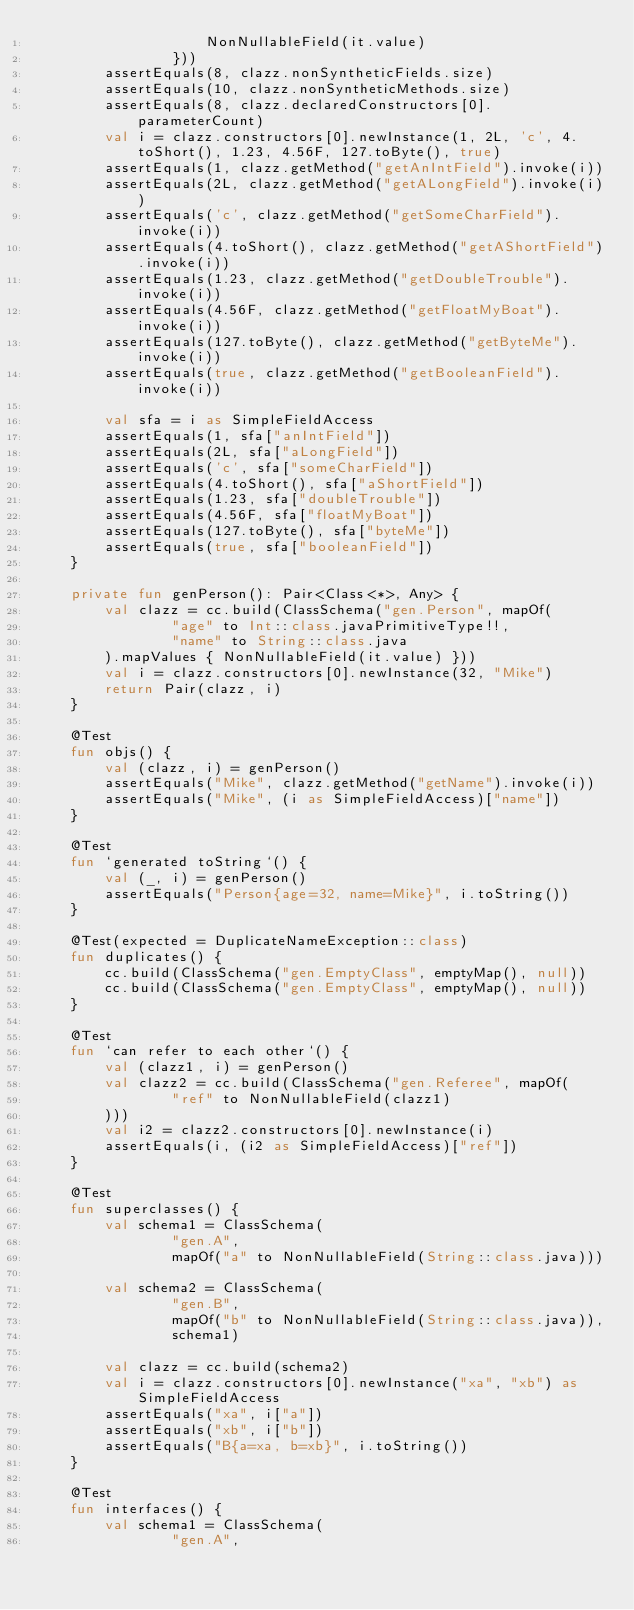<code> <loc_0><loc_0><loc_500><loc_500><_Kotlin_>                    NonNullableField(it.value)
                }))
        assertEquals(8, clazz.nonSyntheticFields.size)
        assertEquals(10, clazz.nonSyntheticMethods.size)
        assertEquals(8, clazz.declaredConstructors[0].parameterCount)
        val i = clazz.constructors[0].newInstance(1, 2L, 'c', 4.toShort(), 1.23, 4.56F, 127.toByte(), true)
        assertEquals(1, clazz.getMethod("getAnIntField").invoke(i))
        assertEquals(2L, clazz.getMethod("getALongField").invoke(i))
        assertEquals('c', clazz.getMethod("getSomeCharField").invoke(i))
        assertEquals(4.toShort(), clazz.getMethod("getAShortField").invoke(i))
        assertEquals(1.23, clazz.getMethod("getDoubleTrouble").invoke(i))
        assertEquals(4.56F, clazz.getMethod("getFloatMyBoat").invoke(i))
        assertEquals(127.toByte(), clazz.getMethod("getByteMe").invoke(i))
        assertEquals(true, clazz.getMethod("getBooleanField").invoke(i))

        val sfa = i as SimpleFieldAccess
        assertEquals(1, sfa["anIntField"])
        assertEquals(2L, sfa["aLongField"])
        assertEquals('c', sfa["someCharField"])
        assertEquals(4.toShort(), sfa["aShortField"])
        assertEquals(1.23, sfa["doubleTrouble"])
        assertEquals(4.56F, sfa["floatMyBoat"])
        assertEquals(127.toByte(), sfa["byteMe"])
        assertEquals(true, sfa["booleanField"])
    }

    private fun genPerson(): Pair<Class<*>, Any> {
        val clazz = cc.build(ClassSchema("gen.Person", mapOf(
                "age" to Int::class.javaPrimitiveType!!,
                "name" to String::class.java
        ).mapValues { NonNullableField(it.value) }))
        val i = clazz.constructors[0].newInstance(32, "Mike")
        return Pair(clazz, i)
    }

    @Test
    fun objs() {
        val (clazz, i) = genPerson()
        assertEquals("Mike", clazz.getMethod("getName").invoke(i))
        assertEquals("Mike", (i as SimpleFieldAccess)["name"])
    }

    @Test
    fun `generated toString`() {
        val (_, i) = genPerson()
        assertEquals("Person{age=32, name=Mike}", i.toString())
    }

    @Test(expected = DuplicateNameException::class)
    fun duplicates() {
        cc.build(ClassSchema("gen.EmptyClass", emptyMap(), null))
        cc.build(ClassSchema("gen.EmptyClass", emptyMap(), null))
    }

    @Test
    fun `can refer to each other`() {
        val (clazz1, i) = genPerson()
        val clazz2 = cc.build(ClassSchema("gen.Referee", mapOf(
                "ref" to NonNullableField(clazz1)
        )))
        val i2 = clazz2.constructors[0].newInstance(i)
        assertEquals(i, (i2 as SimpleFieldAccess)["ref"])
    }

    @Test
    fun superclasses() {
        val schema1 = ClassSchema(
                "gen.A",
                mapOf("a" to NonNullableField(String::class.java)))

        val schema2 = ClassSchema(
                "gen.B",
                mapOf("b" to NonNullableField(String::class.java)),
                schema1)

        val clazz = cc.build(schema2)
        val i = clazz.constructors[0].newInstance("xa", "xb") as SimpleFieldAccess
        assertEquals("xa", i["a"])
        assertEquals("xb", i["b"])
        assertEquals("B{a=xa, b=xb}", i.toString())
    }

    @Test
    fun interfaces() {
        val schema1 = ClassSchema(
                "gen.A",</code> 